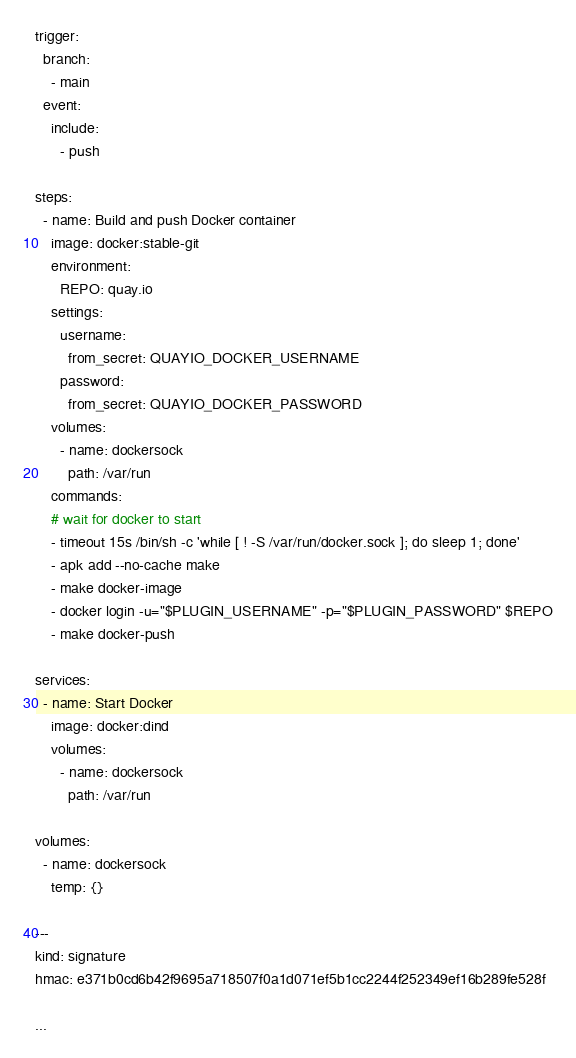Convert code to text. <code><loc_0><loc_0><loc_500><loc_500><_YAML_>trigger:
  branch:
    - main
  event:
    include:
      - push

steps:
  - name: Build and push Docker container
    image: docker:stable-git
    environment:
      REPO: quay.io
    settings:
      username:
        from_secret: QUAYIO_DOCKER_USERNAME
      password:
        from_secret: QUAYIO_DOCKER_PASSWORD
    volumes:
      - name: dockersock
        path: /var/run
    commands:
    # wait for docker to start
    - timeout 15s /bin/sh -c 'while [ ! -S /var/run/docker.sock ]; do sleep 1; done'
    - apk add --no-cache make
    - make docker-image
    - docker login -u="$PLUGIN_USERNAME" -p="$PLUGIN_PASSWORD" $REPO
    - make docker-push

services:
  - name: Start Docker
    image: docker:dind
    volumes:
      - name: dockersock
        path: /var/run

volumes:
  - name: dockersock
    temp: {}

---
kind: signature
hmac: e371b0cd6b42f9695a718507f0a1d071ef5b1cc2244f252349ef16b289fe528f

...
</code> 